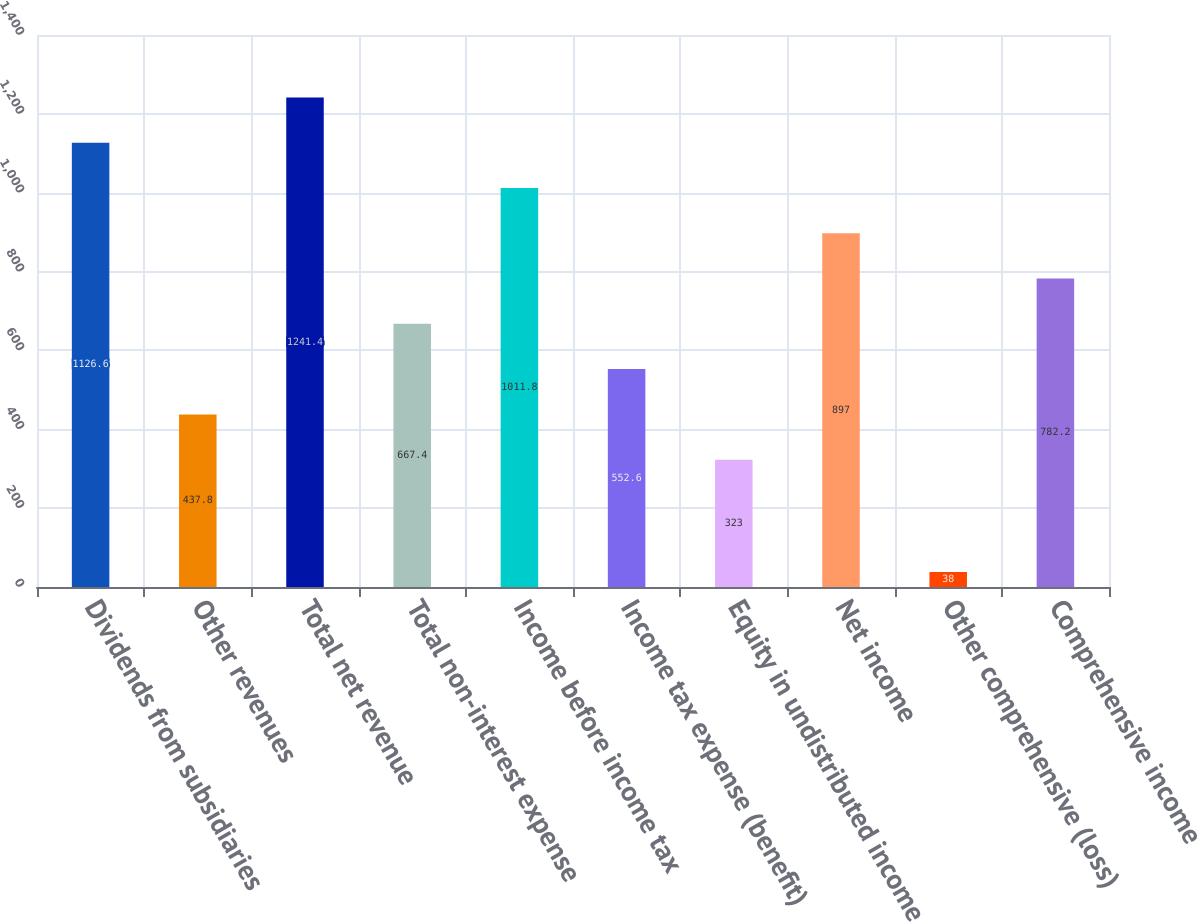Convert chart to OTSL. <chart><loc_0><loc_0><loc_500><loc_500><bar_chart><fcel>Dividends from subsidiaries<fcel>Other revenues<fcel>Total net revenue<fcel>Total non-interest expense<fcel>Income before income tax<fcel>Income tax expense (benefit)<fcel>Equity in undistributed income<fcel>Net income<fcel>Other comprehensive (loss)<fcel>Comprehensive income<nl><fcel>1126.6<fcel>437.8<fcel>1241.4<fcel>667.4<fcel>1011.8<fcel>552.6<fcel>323<fcel>897<fcel>38<fcel>782.2<nl></chart> 